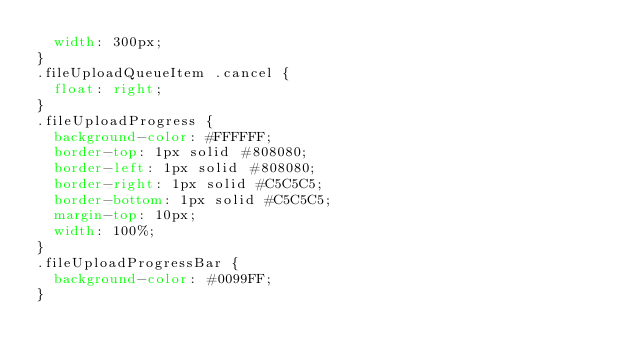<code> <loc_0><loc_0><loc_500><loc_500><_CSS_>	width: 300px;
}
.fileUploadQueueItem .cancel {
	float: right;
}
.fileUploadProgress {
	background-color: #FFFFFF;
	border-top: 1px solid #808080;
	border-left: 1px solid #808080;
	border-right: 1px solid #C5C5C5;
	border-bottom: 1px solid #C5C5C5;
	margin-top: 10px;
	width: 100%;
}
.fileUploadProgressBar {
	background-color: #0099FF;
}</code> 